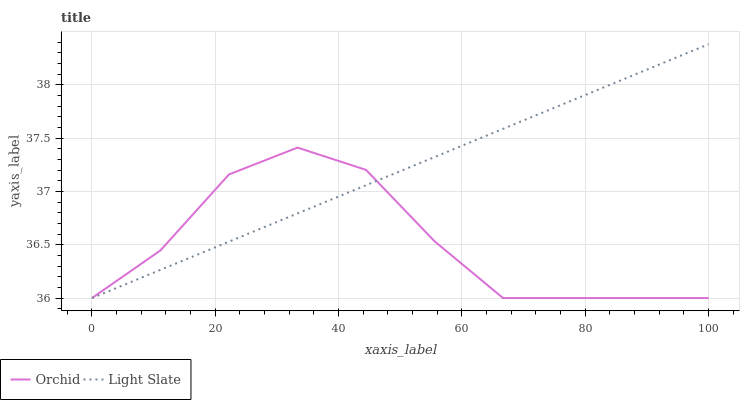Does Orchid have the minimum area under the curve?
Answer yes or no. Yes. Does Light Slate have the maximum area under the curve?
Answer yes or no. Yes. Does Orchid have the maximum area under the curve?
Answer yes or no. No. Is Light Slate the smoothest?
Answer yes or no. Yes. Is Orchid the roughest?
Answer yes or no. Yes. Is Orchid the smoothest?
Answer yes or no. No. Does Light Slate have the lowest value?
Answer yes or no. Yes. Does Light Slate have the highest value?
Answer yes or no. Yes. Does Orchid have the highest value?
Answer yes or no. No. Does Light Slate intersect Orchid?
Answer yes or no. Yes. Is Light Slate less than Orchid?
Answer yes or no. No. Is Light Slate greater than Orchid?
Answer yes or no. No. 